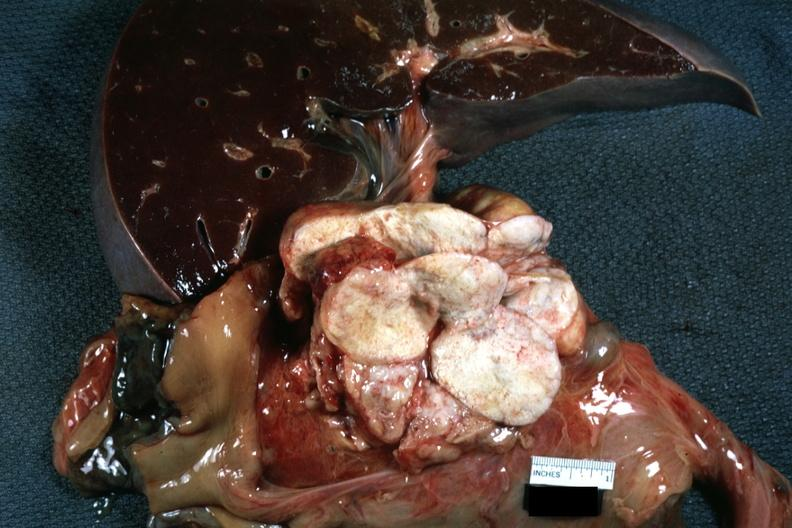how is nodes at tail of pancreas replaced replaced by lung carcinoma?
Answer the question using a single word or phrase. Metastatic 